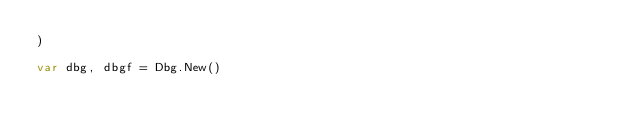<code> <loc_0><loc_0><loc_500><loc_500><_Go_>)

var dbg, dbgf = Dbg.New()
</code> 